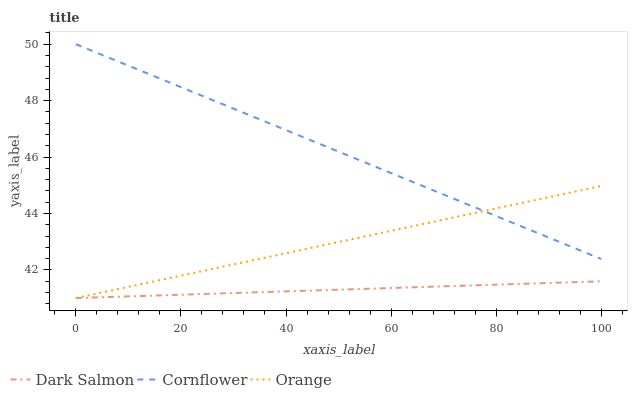Does Dark Salmon have the minimum area under the curve?
Answer yes or no. Yes. Does Cornflower have the maximum area under the curve?
Answer yes or no. Yes. Does Cornflower have the minimum area under the curve?
Answer yes or no. No. Does Dark Salmon have the maximum area under the curve?
Answer yes or no. No. Is Orange the smoothest?
Answer yes or no. Yes. Is Dark Salmon the roughest?
Answer yes or no. Yes. Is Dark Salmon the smoothest?
Answer yes or no. No. Is Cornflower the roughest?
Answer yes or no. No. Does Orange have the lowest value?
Answer yes or no. Yes. Does Cornflower have the lowest value?
Answer yes or no. No. Does Cornflower have the highest value?
Answer yes or no. Yes. Does Dark Salmon have the highest value?
Answer yes or no. No. Is Dark Salmon less than Cornflower?
Answer yes or no. Yes. Is Cornflower greater than Dark Salmon?
Answer yes or no. Yes. Does Orange intersect Cornflower?
Answer yes or no. Yes. Is Orange less than Cornflower?
Answer yes or no. No. Is Orange greater than Cornflower?
Answer yes or no. No. Does Dark Salmon intersect Cornflower?
Answer yes or no. No. 